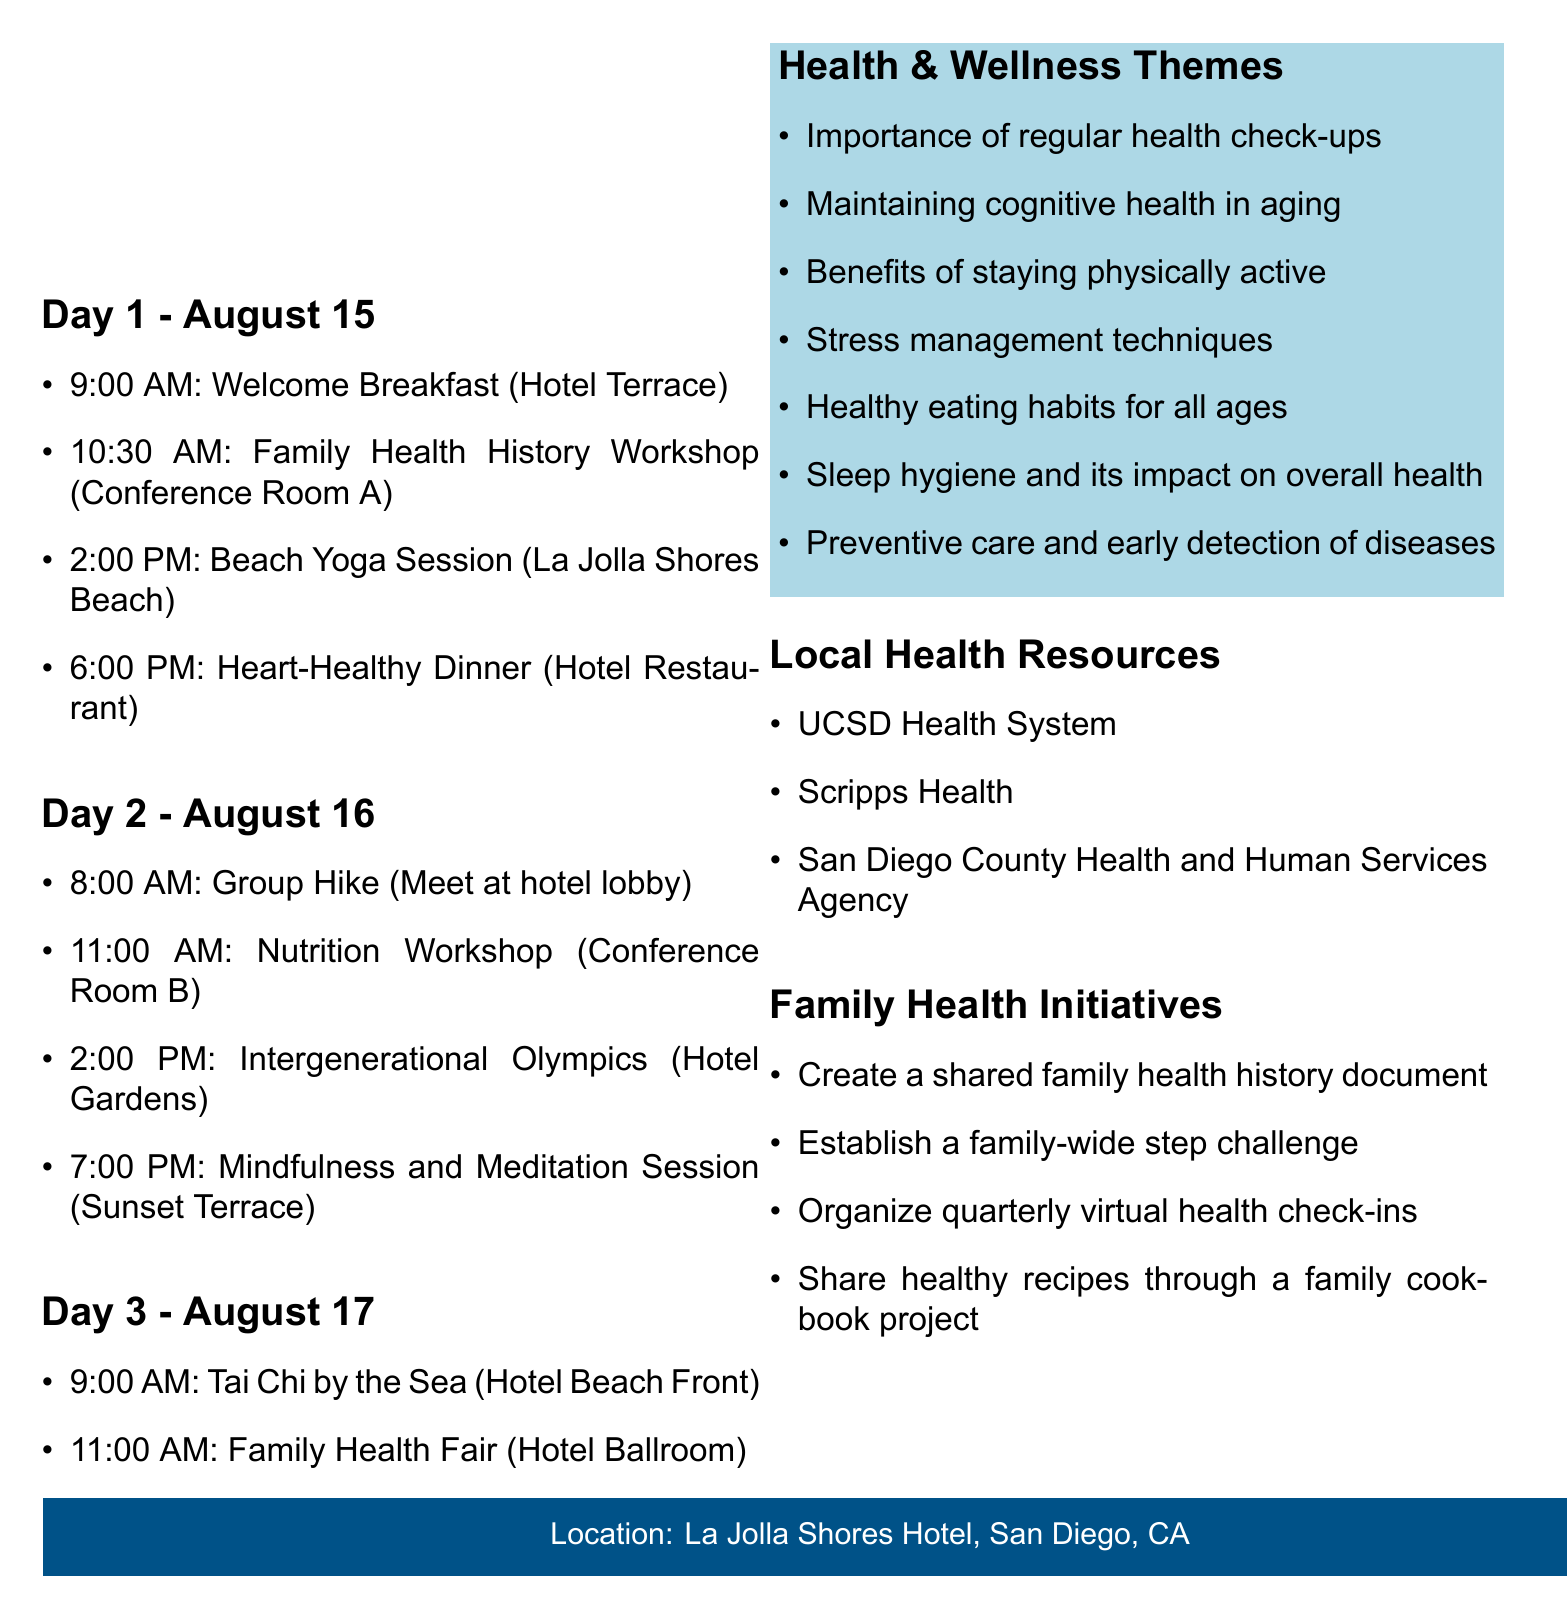What is the name of the event? The name of the event is explicitly stated in the document as "Johnson Family Reunion: Health & Wellness Edition."
Answer: Johnson Family Reunion: Health & Wellness Edition When is the family reunion scheduled? The date of the event is detailed in the document, which states it takes place from August 15-17, 2023.
Answer: August 15-17, 2023 What activity starts at 10:30 AM on Day 1? The document lists the scheduled activities, identifying the Family Health History Workshop as the activity at that time.
Answer: Family Health History Workshop Who leads the Tai Chi session? The document mentions that the Tai Chi session is led by an instructor from the Shiley-Marcos Alzheimer's Disease Research Center.
Answer: Shiley-Marcos Alzheimer's Disease Research Center What health theme focuses on aging? In the themes section, the document specifies the topic of maintaining cognitive health in aging as a focus area.
Answer: Maintaining cognitive health in aging How many days does the reunion last? Based on the dates mentioned in the document, the reunion spans three days.
Answer: Three days What is the location of the event? The document states the event will take place at La Jolla Shores Hotel, San Diego, CA.
Answer: La Jolla Shores Hotel, San Diego, CA What is one of the family health initiatives? The document lists initiatives, one of which includes creating a shared family health history document.
Answer: Creating a shared family health history document 